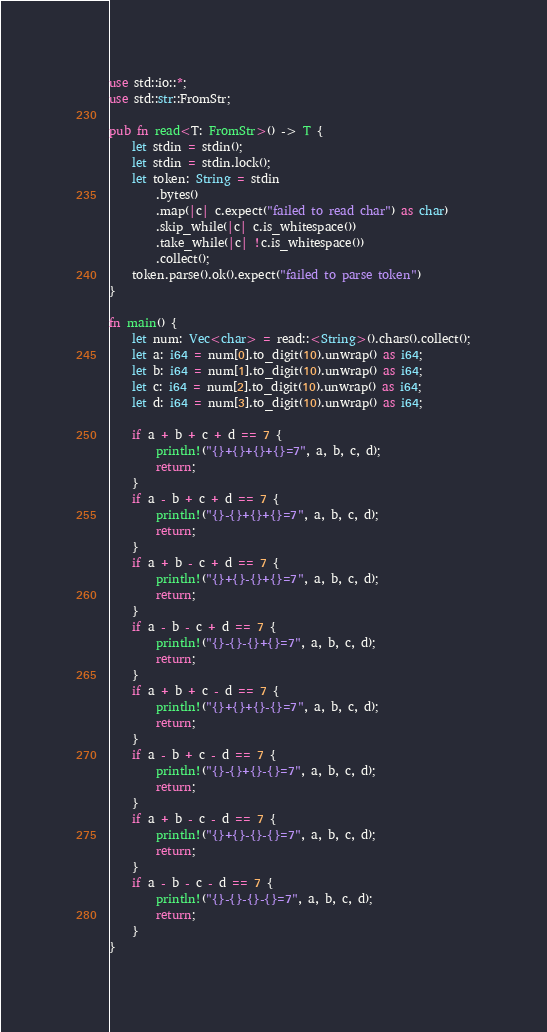Convert code to text. <code><loc_0><loc_0><loc_500><loc_500><_Rust_>use std::io::*;
use std::str::FromStr;

pub fn read<T: FromStr>() -> T {
    let stdin = stdin();
    let stdin = stdin.lock();
    let token: String = stdin
        .bytes()
        .map(|c| c.expect("failed to read char") as char)
        .skip_while(|c| c.is_whitespace())
        .take_while(|c| !c.is_whitespace())
        .collect();
    token.parse().ok().expect("failed to parse token")
}

fn main() {
    let num: Vec<char> = read::<String>().chars().collect();
    let a: i64 = num[0].to_digit(10).unwrap() as i64;
    let b: i64 = num[1].to_digit(10).unwrap() as i64;
    let c: i64 = num[2].to_digit(10).unwrap() as i64;
    let d: i64 = num[3].to_digit(10).unwrap() as i64;

    if a + b + c + d == 7 {
        println!("{}+{}+{}+{}=7", a, b, c, d);
        return;
    }
    if a - b + c + d == 7 {
        println!("{}-{}+{}+{}=7", a, b, c, d);
        return;
    }
    if a + b - c + d == 7 {
        println!("{}+{}-{}+{}=7", a, b, c, d);
        return;
    }
    if a - b - c + d == 7 {
        println!("{}-{}-{}+{}=7", a, b, c, d);
        return;
    }
    if a + b + c - d == 7 {
        println!("{}+{}+{}-{}=7", a, b, c, d);
        return;
    }
    if a - b + c - d == 7 {
        println!("{}-{}+{}-{}=7", a, b, c, d);
        return;
    }
    if a + b - c - d == 7 {
        println!("{}+{}-{}-{}=7", a, b, c, d);
        return;
    }
    if a - b - c - d == 7 {
        println!("{}-{}-{}-{}=7", a, b, c, d);
        return;
    }
}
</code> 